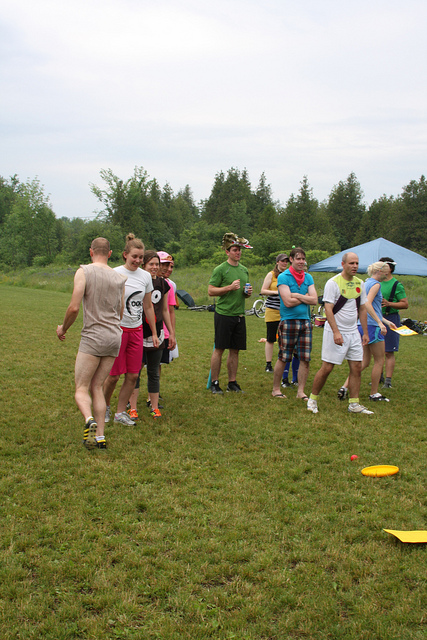Imagine a scenario where this event turns into a thrilling adventure. What could happen? As the group is enjoying their game of frisbee, they suddenly notice a bright light in the sky. The ground rumbles slightly, and an alien spacecraft lands nearby. The people, initially startled, are soon greeted by friendly extraterrestrials who invite them on an interstellar journey. The group excitedly boards the spaceship, embarking on a once-in-a-lifetime adventure through the cosmos, visiting distant planets, and making new alien friends. That's an amazing twist! Now, can you imagine a more realistic surprising event that could happen during their gathering? Halfway through their frisbee game, the group hears a rustling in the bushes and discovers a family of deer cautiously approaching the field. The animals are curious but not frightened, and they slowly make their way closer, much to the delight of the participants. The group takes a break from their activity to quietly observe the deer, taking photos and enjoying this unexpected encounter with wildlife which adds a magical touch to their day. 